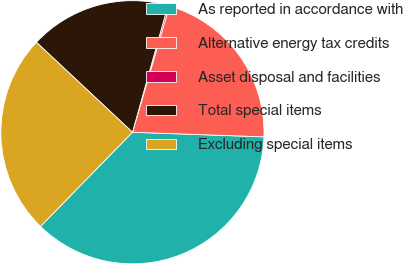<chart> <loc_0><loc_0><loc_500><loc_500><pie_chart><fcel>As reported in accordance with<fcel>Alternative energy tax credits<fcel>Asset disposal and facilities<fcel>Total special items<fcel>Excluding special items<nl><fcel>36.75%<fcel>21.01%<fcel>0.2%<fcel>17.36%<fcel>24.67%<nl></chart> 